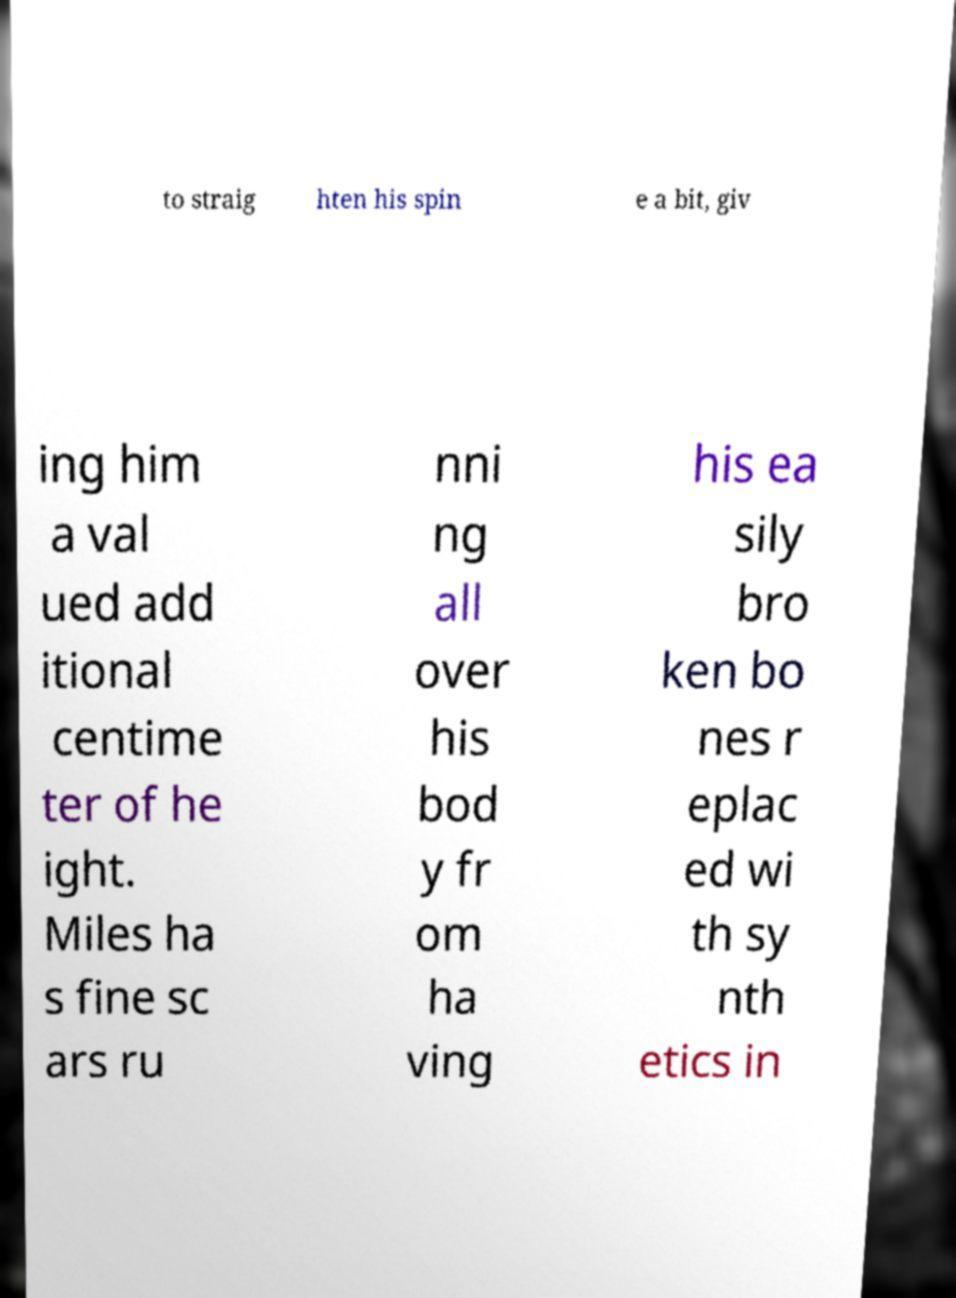Please read and relay the text visible in this image. What does it say? to straig hten his spin e a bit, giv ing him a val ued add itional centime ter of he ight. Miles ha s fine sc ars ru nni ng all over his bod y fr om ha ving his ea sily bro ken bo nes r eplac ed wi th sy nth etics in 